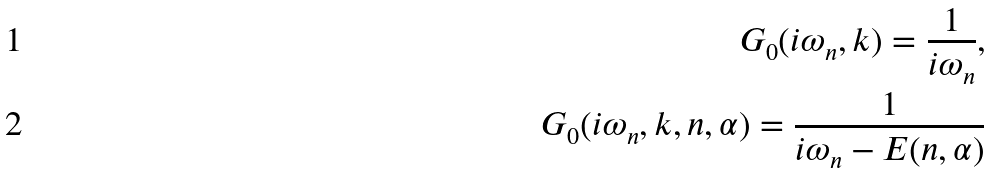Convert formula to latex. <formula><loc_0><loc_0><loc_500><loc_500>G _ { 0 } ( i \omega _ { n } , k ) = \frac { 1 } { i \omega _ { n } } , \\ G _ { 0 } ( i \omega _ { n } , k , n , \alpha ) = \frac { 1 } { i \omega _ { n } - E ( n , \alpha ) }</formula> 